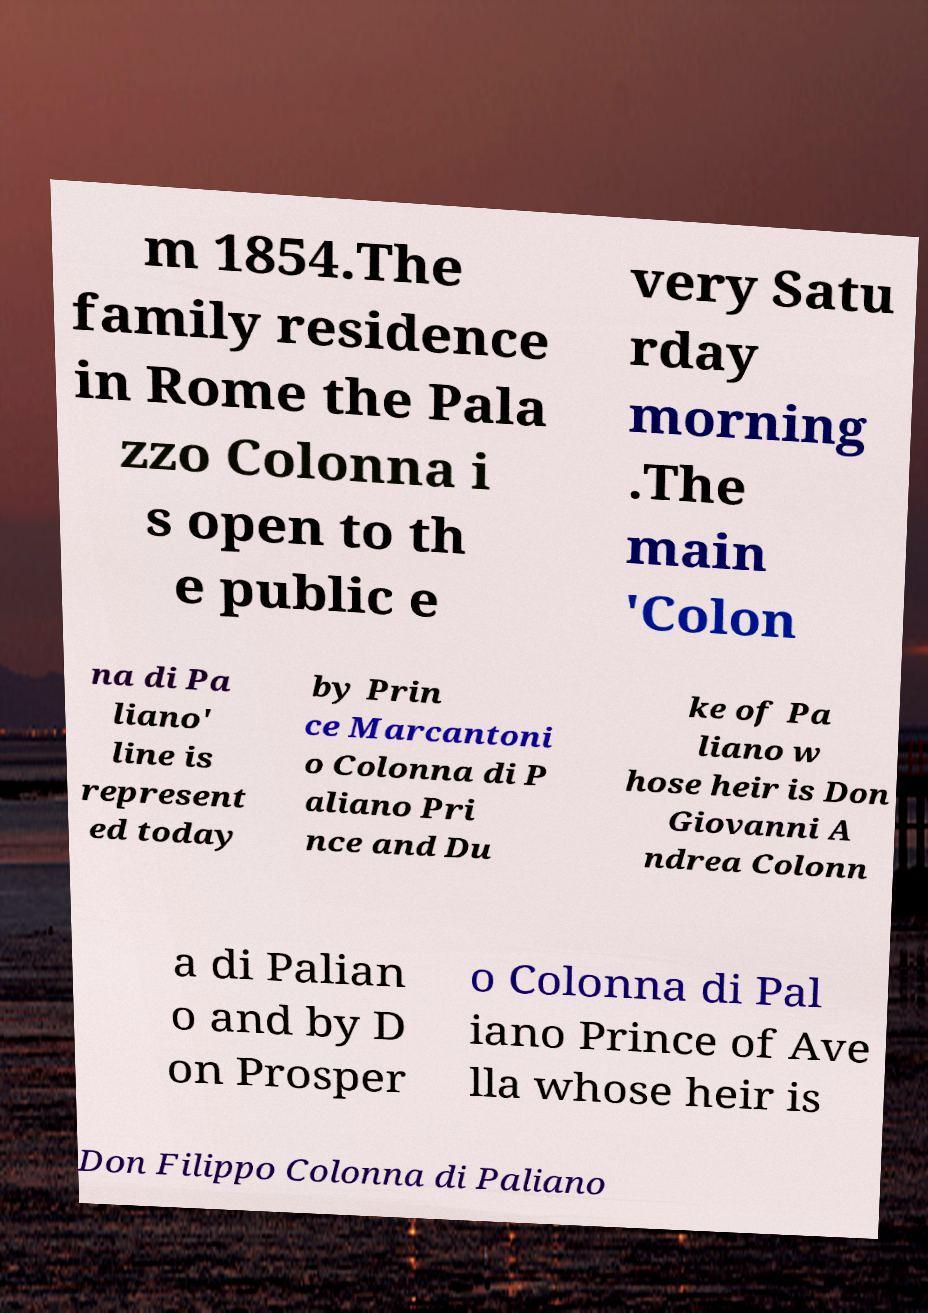Please identify and transcribe the text found in this image. m 1854.The family residence in Rome the Pala zzo Colonna i s open to th e public e very Satu rday morning .The main 'Colon na di Pa liano' line is represent ed today by Prin ce Marcantoni o Colonna di P aliano Pri nce and Du ke of Pa liano w hose heir is Don Giovanni A ndrea Colonn a di Palian o and by D on Prosper o Colonna di Pal iano Prince of Ave lla whose heir is Don Filippo Colonna di Paliano 